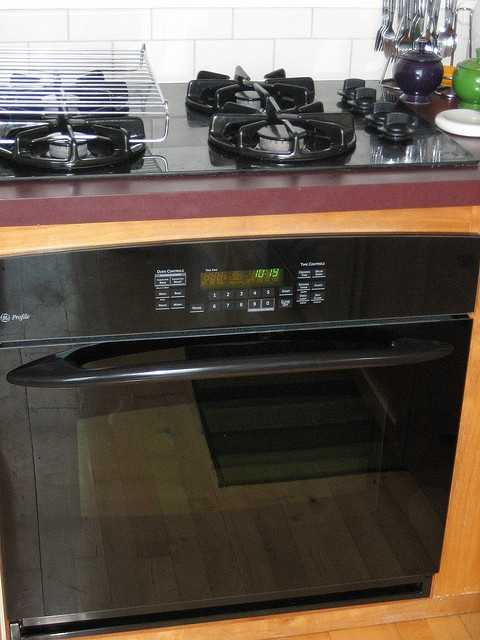Describe the objects in this image and their specific colors. I can see oven in black, white, gray, and brown tones, fork in white, gray, darkgray, and lightgray tones, fork in white, gray, darkgray, maroon, and lightgray tones, fork in white, darkgray, gray, and lightgray tones, and fork in white, darkgray, gray, and lightgray tones in this image. 